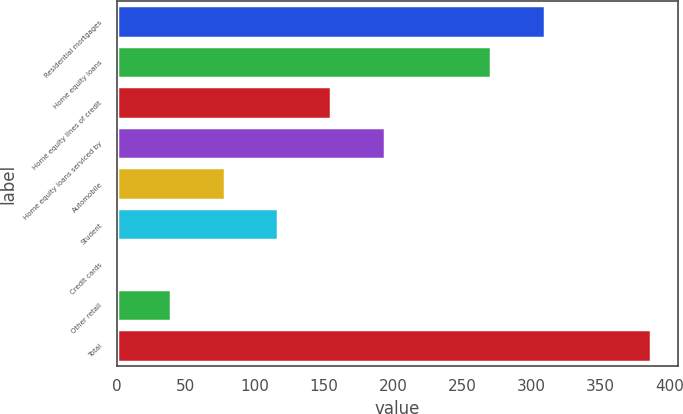<chart> <loc_0><loc_0><loc_500><loc_500><bar_chart><fcel>Residential mortgages<fcel>Home equity loans<fcel>Home equity lines of credit<fcel>Home equity loans serviced by<fcel>Automobile<fcel>Student<fcel>Credit cards<fcel>Other retail<fcel>Total<nl><fcel>309.8<fcel>271.2<fcel>155.4<fcel>194<fcel>78.2<fcel>116.8<fcel>1<fcel>39.6<fcel>387<nl></chart> 